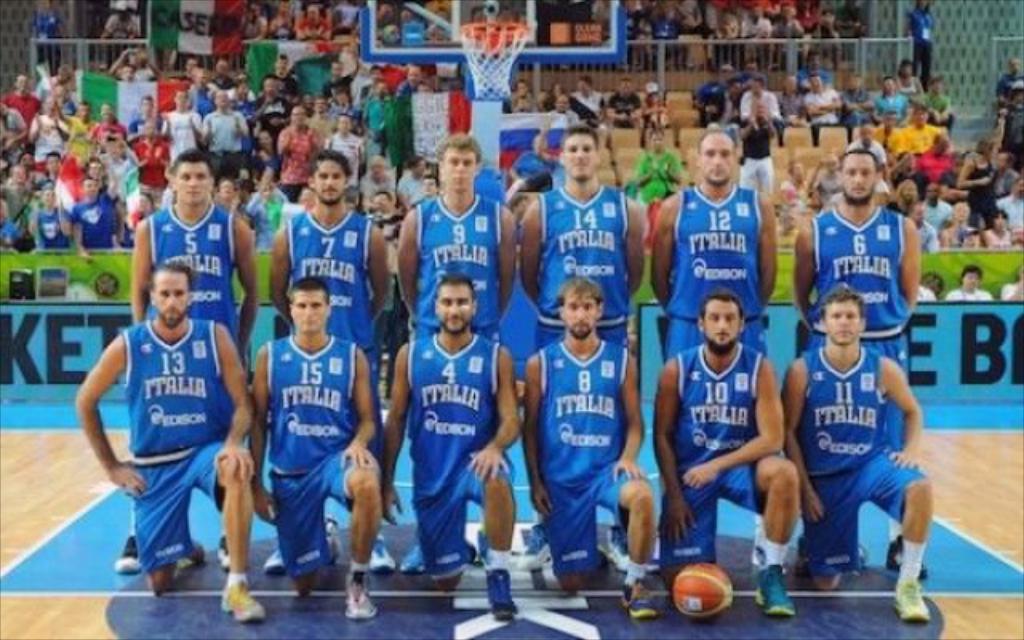What basketball team is it?
Your answer should be very brief. Italia. What number is the guy standing on the far left?
Your answer should be compact. 13. 